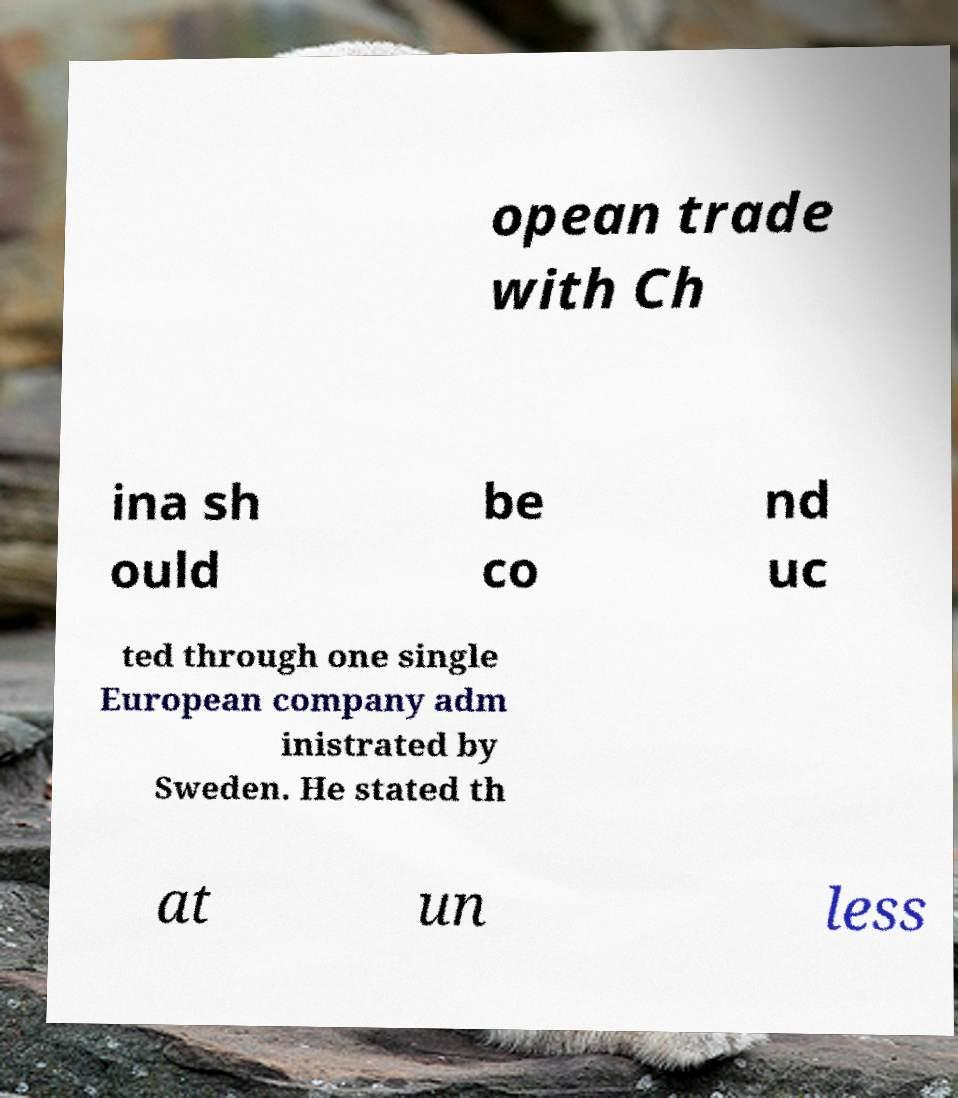Can you read and provide the text displayed in the image?This photo seems to have some interesting text. Can you extract and type it out for me? opean trade with Ch ina sh ould be co nd uc ted through one single European company adm inistrated by Sweden. He stated th at un less 